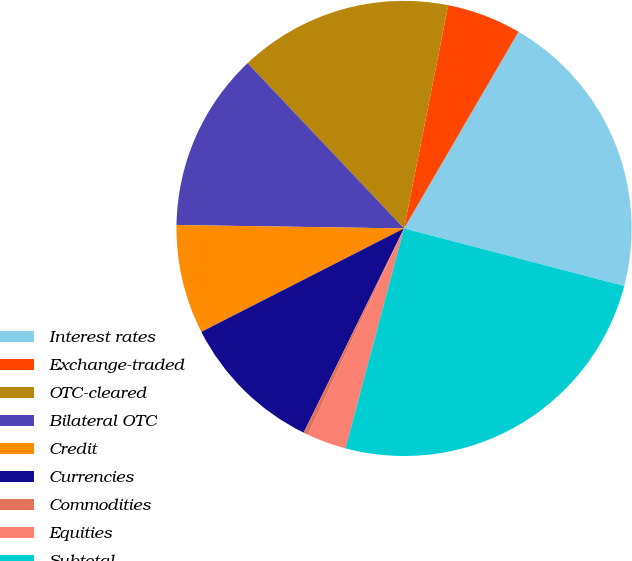Convert chart. <chart><loc_0><loc_0><loc_500><loc_500><pie_chart><fcel>Interest rates<fcel>Exchange-traded<fcel>OTC-cleared<fcel>Bilateral OTC<fcel>Credit<fcel>Currencies<fcel>Commodities<fcel>Equities<fcel>Subtotal<nl><fcel>20.68%<fcel>5.28%<fcel>15.17%<fcel>12.7%<fcel>7.75%<fcel>10.22%<fcel>0.33%<fcel>2.8%<fcel>25.07%<nl></chart> 